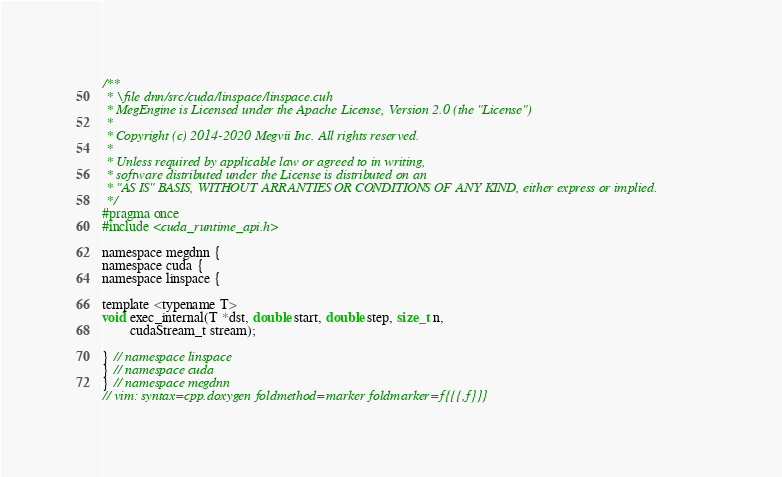<code> <loc_0><loc_0><loc_500><loc_500><_Cuda_>/**
 * \file dnn/src/cuda/linspace/linspace.cuh
 * MegEngine is Licensed under the Apache License, Version 2.0 (the "License")
 *
 * Copyright (c) 2014-2020 Megvii Inc. All rights reserved.
 *
 * Unless required by applicable law or agreed to in writing,
 * software distributed under the License is distributed on an
 * "AS IS" BASIS, WITHOUT ARRANTIES OR CONDITIONS OF ANY KIND, either express or implied.
 */
#pragma once
#include <cuda_runtime_api.h>

namespace megdnn {
namespace cuda {
namespace linspace {

template <typename T>
void exec_internal(T *dst, double start, double step, size_t n,
        cudaStream_t stream);

} // namespace linspace
} // namespace cuda
} // namespace megdnn
// vim: syntax=cpp.doxygen foldmethod=marker foldmarker=f{{{,f}}}
</code> 